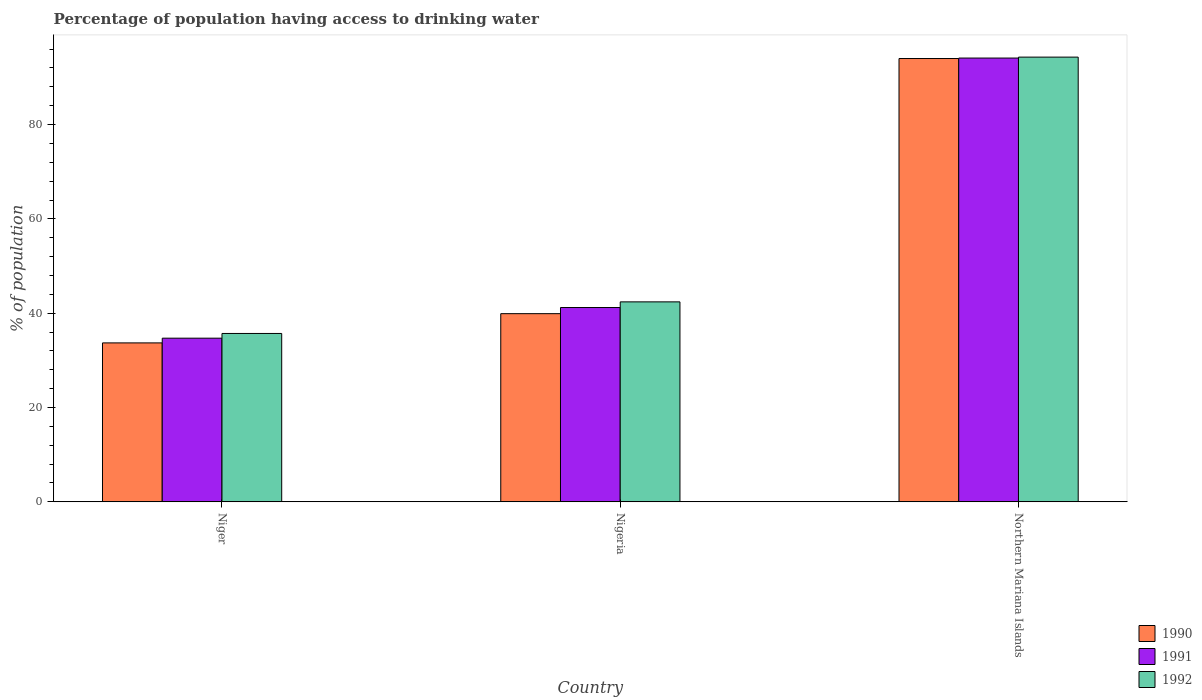Are the number of bars per tick equal to the number of legend labels?
Ensure brevity in your answer.  Yes. Are the number of bars on each tick of the X-axis equal?
Provide a short and direct response. Yes. What is the label of the 3rd group of bars from the left?
Keep it short and to the point. Northern Mariana Islands. What is the percentage of population having access to drinking water in 1992 in Northern Mariana Islands?
Your answer should be very brief. 94.3. Across all countries, what is the maximum percentage of population having access to drinking water in 1992?
Provide a succinct answer. 94.3. Across all countries, what is the minimum percentage of population having access to drinking water in 1992?
Your answer should be compact. 35.7. In which country was the percentage of population having access to drinking water in 1992 maximum?
Give a very brief answer. Northern Mariana Islands. In which country was the percentage of population having access to drinking water in 1990 minimum?
Make the answer very short. Niger. What is the total percentage of population having access to drinking water in 1991 in the graph?
Provide a short and direct response. 170. What is the difference between the percentage of population having access to drinking water in 1992 in Niger and that in Nigeria?
Offer a terse response. -6.7. What is the difference between the percentage of population having access to drinking water in 1990 in Nigeria and the percentage of population having access to drinking water in 1992 in Niger?
Offer a terse response. 4.2. What is the average percentage of population having access to drinking water in 1991 per country?
Provide a short and direct response. 56.67. What is the difference between the percentage of population having access to drinking water of/in 1990 and percentage of population having access to drinking water of/in 1991 in Northern Mariana Islands?
Provide a short and direct response. -0.1. What is the ratio of the percentage of population having access to drinking water in 1992 in Niger to that in Nigeria?
Give a very brief answer. 0.84. Is the percentage of population having access to drinking water in 1990 in Niger less than that in Northern Mariana Islands?
Provide a short and direct response. Yes. Is the difference between the percentage of population having access to drinking water in 1990 in Niger and Nigeria greater than the difference between the percentage of population having access to drinking water in 1991 in Niger and Nigeria?
Make the answer very short. Yes. What is the difference between the highest and the second highest percentage of population having access to drinking water in 1990?
Your answer should be very brief. -60.3. What is the difference between the highest and the lowest percentage of population having access to drinking water in 1991?
Make the answer very short. 59.4. What does the 2nd bar from the right in Nigeria represents?
Your answer should be compact. 1991. Is it the case that in every country, the sum of the percentage of population having access to drinking water in 1991 and percentage of population having access to drinking water in 1990 is greater than the percentage of population having access to drinking water in 1992?
Give a very brief answer. Yes. Are all the bars in the graph horizontal?
Provide a succinct answer. No. What is the difference between two consecutive major ticks on the Y-axis?
Give a very brief answer. 20. Are the values on the major ticks of Y-axis written in scientific E-notation?
Provide a short and direct response. No. Does the graph contain any zero values?
Keep it short and to the point. No. How many legend labels are there?
Make the answer very short. 3. What is the title of the graph?
Your answer should be very brief. Percentage of population having access to drinking water. Does "1966" appear as one of the legend labels in the graph?
Provide a short and direct response. No. What is the label or title of the Y-axis?
Your response must be concise. % of population. What is the % of population in 1990 in Niger?
Your response must be concise. 33.7. What is the % of population in 1991 in Niger?
Make the answer very short. 34.7. What is the % of population of 1992 in Niger?
Provide a succinct answer. 35.7. What is the % of population of 1990 in Nigeria?
Give a very brief answer. 39.9. What is the % of population of 1991 in Nigeria?
Provide a succinct answer. 41.2. What is the % of population of 1992 in Nigeria?
Your answer should be compact. 42.4. What is the % of population of 1990 in Northern Mariana Islands?
Your response must be concise. 94. What is the % of population in 1991 in Northern Mariana Islands?
Your response must be concise. 94.1. What is the % of population of 1992 in Northern Mariana Islands?
Offer a terse response. 94.3. Across all countries, what is the maximum % of population of 1990?
Provide a short and direct response. 94. Across all countries, what is the maximum % of population in 1991?
Give a very brief answer. 94.1. Across all countries, what is the maximum % of population in 1992?
Ensure brevity in your answer.  94.3. Across all countries, what is the minimum % of population in 1990?
Give a very brief answer. 33.7. Across all countries, what is the minimum % of population in 1991?
Make the answer very short. 34.7. Across all countries, what is the minimum % of population of 1992?
Offer a very short reply. 35.7. What is the total % of population of 1990 in the graph?
Make the answer very short. 167.6. What is the total % of population of 1991 in the graph?
Give a very brief answer. 170. What is the total % of population in 1992 in the graph?
Your answer should be very brief. 172.4. What is the difference between the % of population in 1991 in Niger and that in Nigeria?
Your answer should be compact. -6.5. What is the difference between the % of population in 1992 in Niger and that in Nigeria?
Your answer should be compact. -6.7. What is the difference between the % of population of 1990 in Niger and that in Northern Mariana Islands?
Give a very brief answer. -60.3. What is the difference between the % of population in 1991 in Niger and that in Northern Mariana Islands?
Offer a very short reply. -59.4. What is the difference between the % of population in 1992 in Niger and that in Northern Mariana Islands?
Offer a terse response. -58.6. What is the difference between the % of population in 1990 in Nigeria and that in Northern Mariana Islands?
Your response must be concise. -54.1. What is the difference between the % of population in 1991 in Nigeria and that in Northern Mariana Islands?
Your answer should be compact. -52.9. What is the difference between the % of population in 1992 in Nigeria and that in Northern Mariana Islands?
Your answer should be compact. -51.9. What is the difference between the % of population in 1990 in Niger and the % of population in 1992 in Nigeria?
Provide a short and direct response. -8.7. What is the difference between the % of population of 1991 in Niger and the % of population of 1992 in Nigeria?
Offer a terse response. -7.7. What is the difference between the % of population of 1990 in Niger and the % of population of 1991 in Northern Mariana Islands?
Your answer should be compact. -60.4. What is the difference between the % of population in 1990 in Niger and the % of population in 1992 in Northern Mariana Islands?
Make the answer very short. -60.6. What is the difference between the % of population in 1991 in Niger and the % of population in 1992 in Northern Mariana Islands?
Provide a succinct answer. -59.6. What is the difference between the % of population in 1990 in Nigeria and the % of population in 1991 in Northern Mariana Islands?
Your answer should be very brief. -54.2. What is the difference between the % of population of 1990 in Nigeria and the % of population of 1992 in Northern Mariana Islands?
Provide a succinct answer. -54.4. What is the difference between the % of population of 1991 in Nigeria and the % of population of 1992 in Northern Mariana Islands?
Provide a short and direct response. -53.1. What is the average % of population in 1990 per country?
Your response must be concise. 55.87. What is the average % of population in 1991 per country?
Your response must be concise. 56.67. What is the average % of population of 1992 per country?
Your response must be concise. 57.47. What is the difference between the % of population in 1990 and % of population in 1991 in Niger?
Offer a very short reply. -1. What is the difference between the % of population of 1991 and % of population of 1992 in Nigeria?
Keep it short and to the point. -1.2. What is the difference between the % of population of 1990 and % of population of 1991 in Northern Mariana Islands?
Your answer should be very brief. -0.1. What is the ratio of the % of population of 1990 in Niger to that in Nigeria?
Keep it short and to the point. 0.84. What is the ratio of the % of population in 1991 in Niger to that in Nigeria?
Your answer should be compact. 0.84. What is the ratio of the % of population in 1992 in Niger to that in Nigeria?
Provide a short and direct response. 0.84. What is the ratio of the % of population of 1990 in Niger to that in Northern Mariana Islands?
Make the answer very short. 0.36. What is the ratio of the % of population in 1991 in Niger to that in Northern Mariana Islands?
Ensure brevity in your answer.  0.37. What is the ratio of the % of population of 1992 in Niger to that in Northern Mariana Islands?
Keep it short and to the point. 0.38. What is the ratio of the % of population in 1990 in Nigeria to that in Northern Mariana Islands?
Keep it short and to the point. 0.42. What is the ratio of the % of population of 1991 in Nigeria to that in Northern Mariana Islands?
Offer a very short reply. 0.44. What is the ratio of the % of population of 1992 in Nigeria to that in Northern Mariana Islands?
Your answer should be very brief. 0.45. What is the difference between the highest and the second highest % of population in 1990?
Offer a very short reply. 54.1. What is the difference between the highest and the second highest % of population in 1991?
Provide a short and direct response. 52.9. What is the difference between the highest and the second highest % of population of 1992?
Your response must be concise. 51.9. What is the difference between the highest and the lowest % of population of 1990?
Keep it short and to the point. 60.3. What is the difference between the highest and the lowest % of population in 1991?
Give a very brief answer. 59.4. What is the difference between the highest and the lowest % of population of 1992?
Offer a terse response. 58.6. 